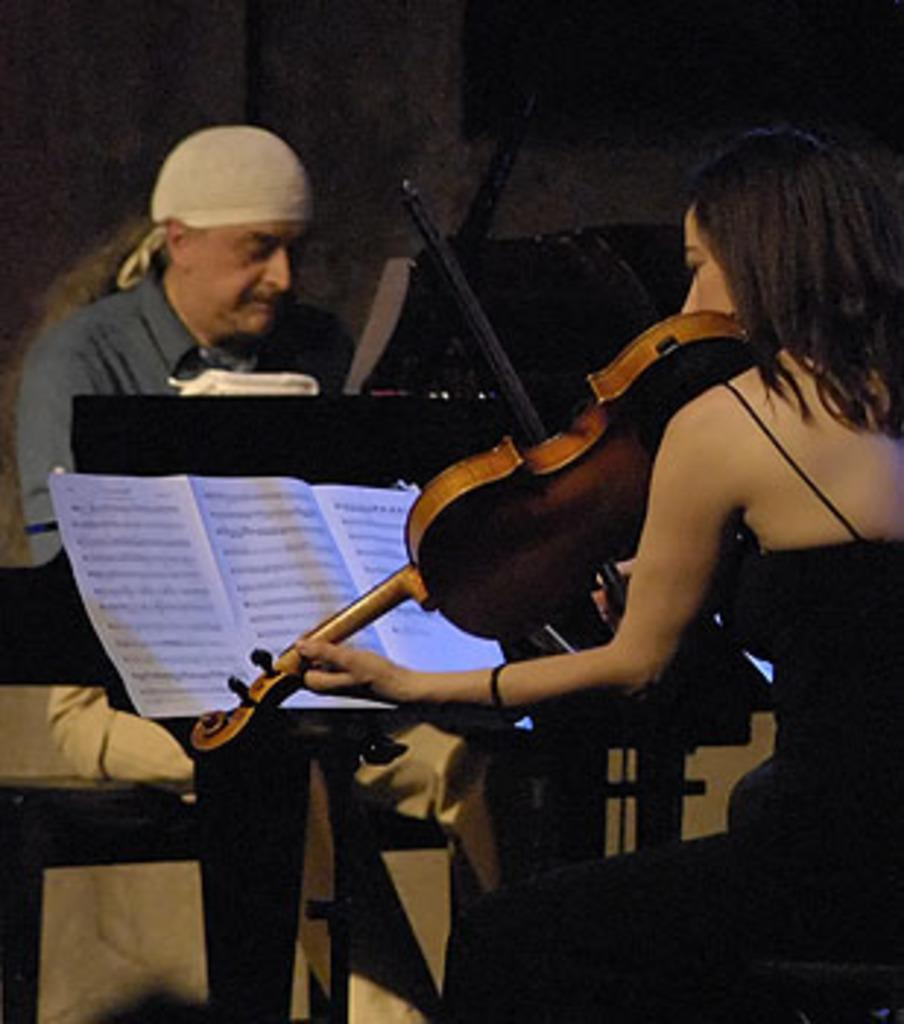How many people are present in the image? There are two people sitting in the image. What is the woman holding in her hand? The woman is holding a violin in her hand. What type of cart can be seen in the image? There is no cart present in the image. What is the woman's chin doing in the image? The woman's chin is not mentioned in the image, and therefore its actions cannot be described. 